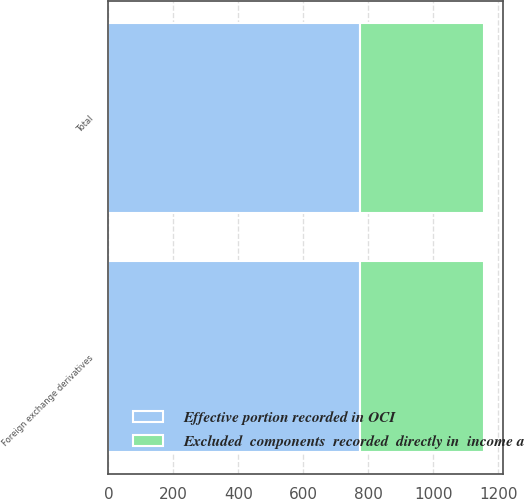<chart> <loc_0><loc_0><loc_500><loc_500><stacked_bar_chart><ecel><fcel>Foreign exchange derivatives<fcel>Total<nl><fcel>Excluded  components  recorded  directly in  income a<fcel>383<fcel>383<nl><fcel>Effective portion recorded in OCI<fcel>773<fcel>773<nl></chart> 